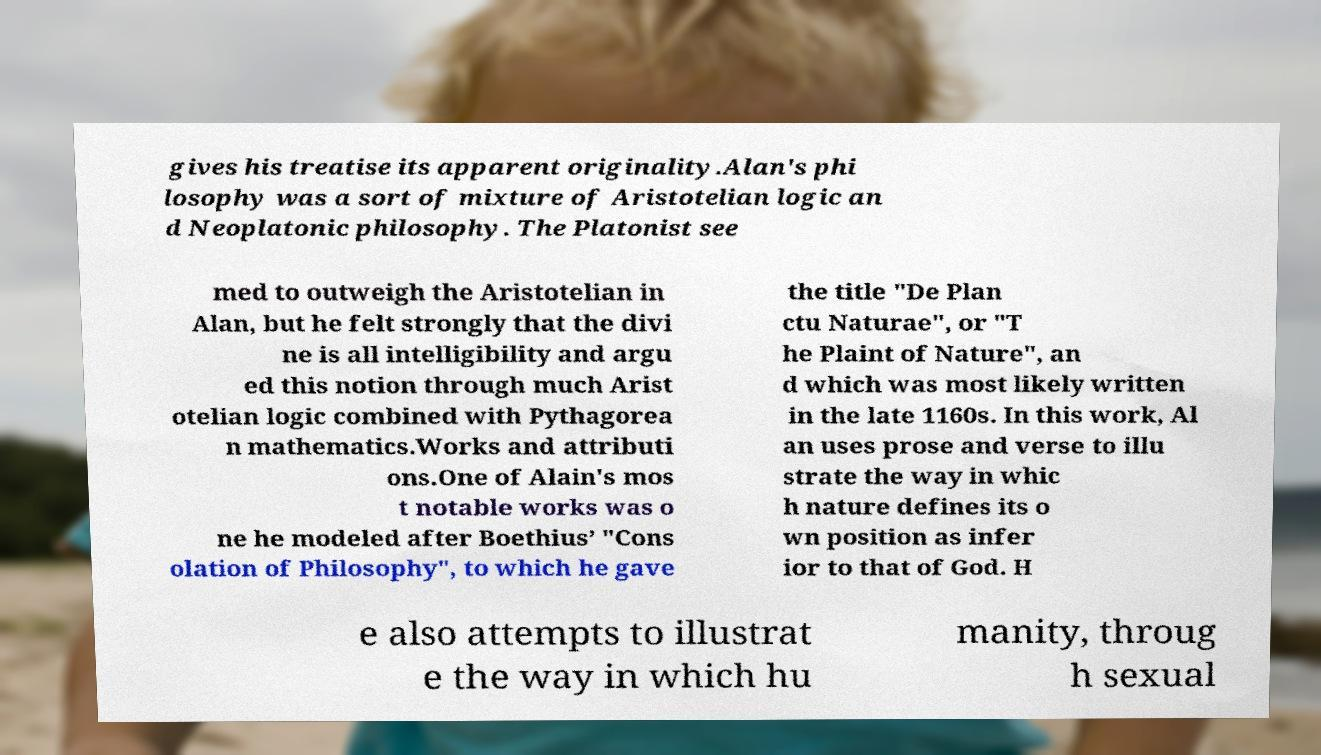Please identify and transcribe the text found in this image. gives his treatise its apparent originality.Alan's phi losophy was a sort of mixture of Aristotelian logic an d Neoplatonic philosophy. The Platonist see med to outweigh the Aristotelian in Alan, but he felt strongly that the divi ne is all intelligibility and argu ed this notion through much Arist otelian logic combined with Pythagorea n mathematics.Works and attributi ons.One of Alain's mos t notable works was o ne he modeled after Boethius’ "Cons olation of Philosophy", to which he gave the title "De Plan ctu Naturae", or "T he Plaint of Nature", an d which was most likely written in the late 1160s. In this work, Al an uses prose and verse to illu strate the way in whic h nature defines its o wn position as infer ior to that of God. H e also attempts to illustrat e the way in which hu manity, throug h sexual 